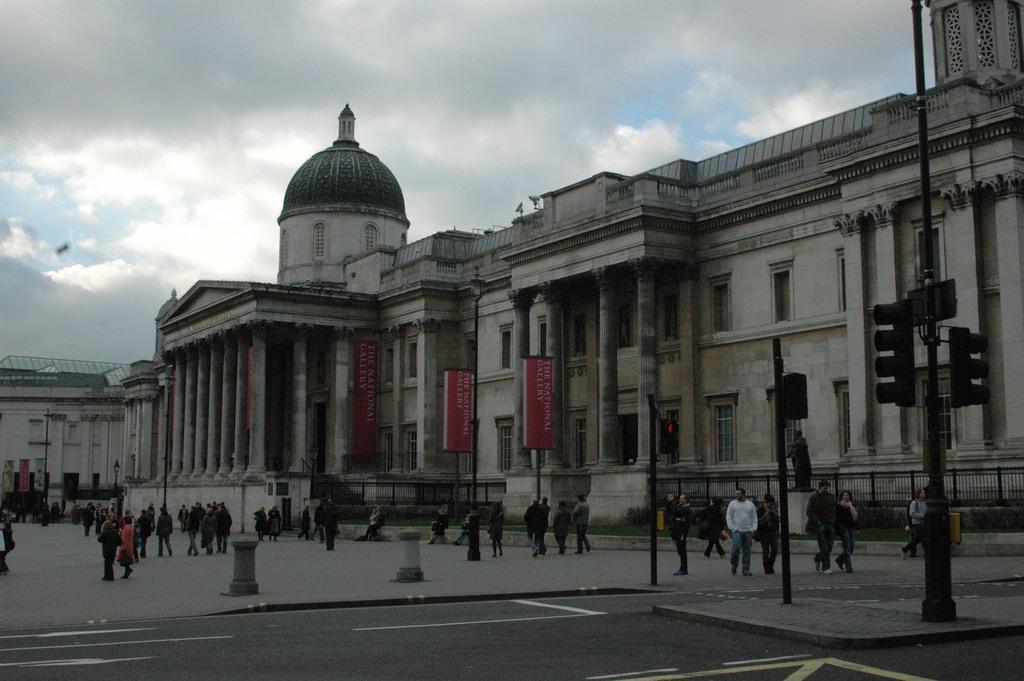Describe this image in one or two sentences. Here in this picture we can see a building with number of windows present over a place and in the front we can see pillars also present and on the road we can see number of people standing and walking and we can see lamp posts present and we can see traffic signal lights present on poles and we can see the sky is fully covered with clouds. 